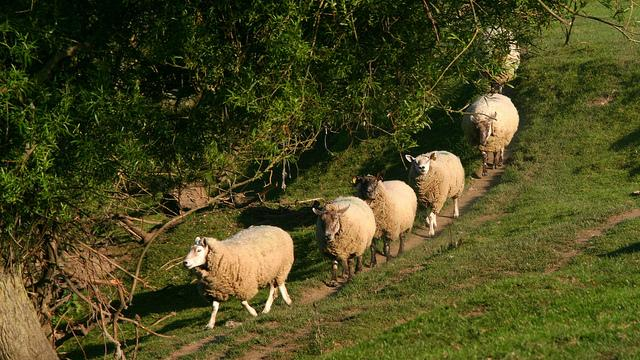What are the animals walking along? path 